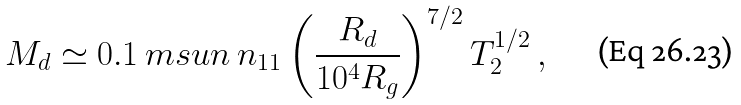<formula> <loc_0><loc_0><loc_500><loc_500>M _ { d } \simeq 0 . 1 \ m s u n \, n _ { 1 1 } \left ( \frac { R _ { d } } { 1 0 ^ { 4 } R _ { g } } \right ) ^ { 7 / 2 } T _ { 2 } ^ { 1 / 2 } \, ,</formula> 